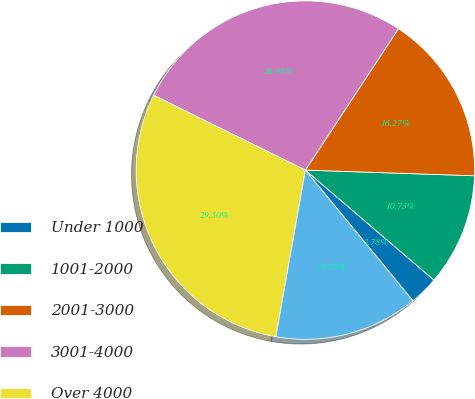Convert chart. <chart><loc_0><loc_0><loc_500><loc_500><pie_chart><fcel>Under 1000<fcel>1001-2000<fcel>2001-3000<fcel>3001-4000<fcel>Over 4000<fcel>All SARs<nl><fcel>2.78%<fcel>10.73%<fcel>16.27%<fcel>26.98%<fcel>29.5%<fcel>13.75%<nl></chart> 